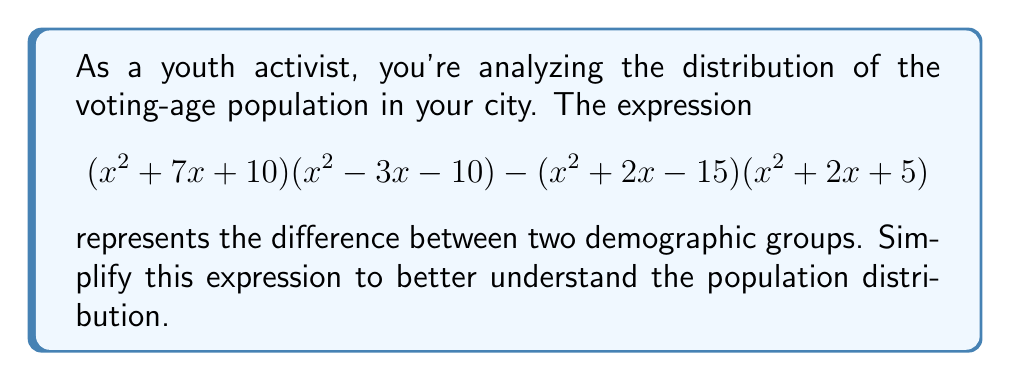Show me your answer to this math problem. Let's approach this step-by-step:

1) First, let's expand $(x^2 + 7x + 10)(x^2 - 3x - 10)$:
   $$(x^4 - 3x^3 - 10x^2) + (7x^3 - 21x^2 - 70x) + (10x^2 - 30x - 100)$$
   $$= x^4 + 4x^3 - 21x^2 - 100x - 100$$

2) Now, let's expand $(x^2 + 2x - 15)(x^2 + 2x + 5)$:
   $$(x^4 + 2x^3 + 5x^2) + (2x^3 + 4x^2 + 10x) + (-15x^2 - 30x - 75)$$
   $$= x^4 + 4x^3 - 6x^2 - 20x - 75$$

3) Now, we subtract the second expanded expression from the first:
   $$(x^4 + 4x^3 - 21x^2 - 100x - 100) - (x^4 + 4x^3 - 6x^2 - 20x - 75)$$

4) Subtracting like terms:
   $$x^4 - x^4 + 4x^3 - 4x^3 - 21x^2 + 6x^2 - 100x + 20x - 100 + 75$$
   $$= -15x^2 - 80x - 25$$

5) This expression can be factored:
   $$-5(3x^2 + 16x + 5)$$

6) The quadratic inside the parentheses can be further factored:
   $$-5(3x + 1)(x + 5)$$

This is the simplified form of the original expression.
Answer: $$-5(3x + 1)(x + 5)$$ 